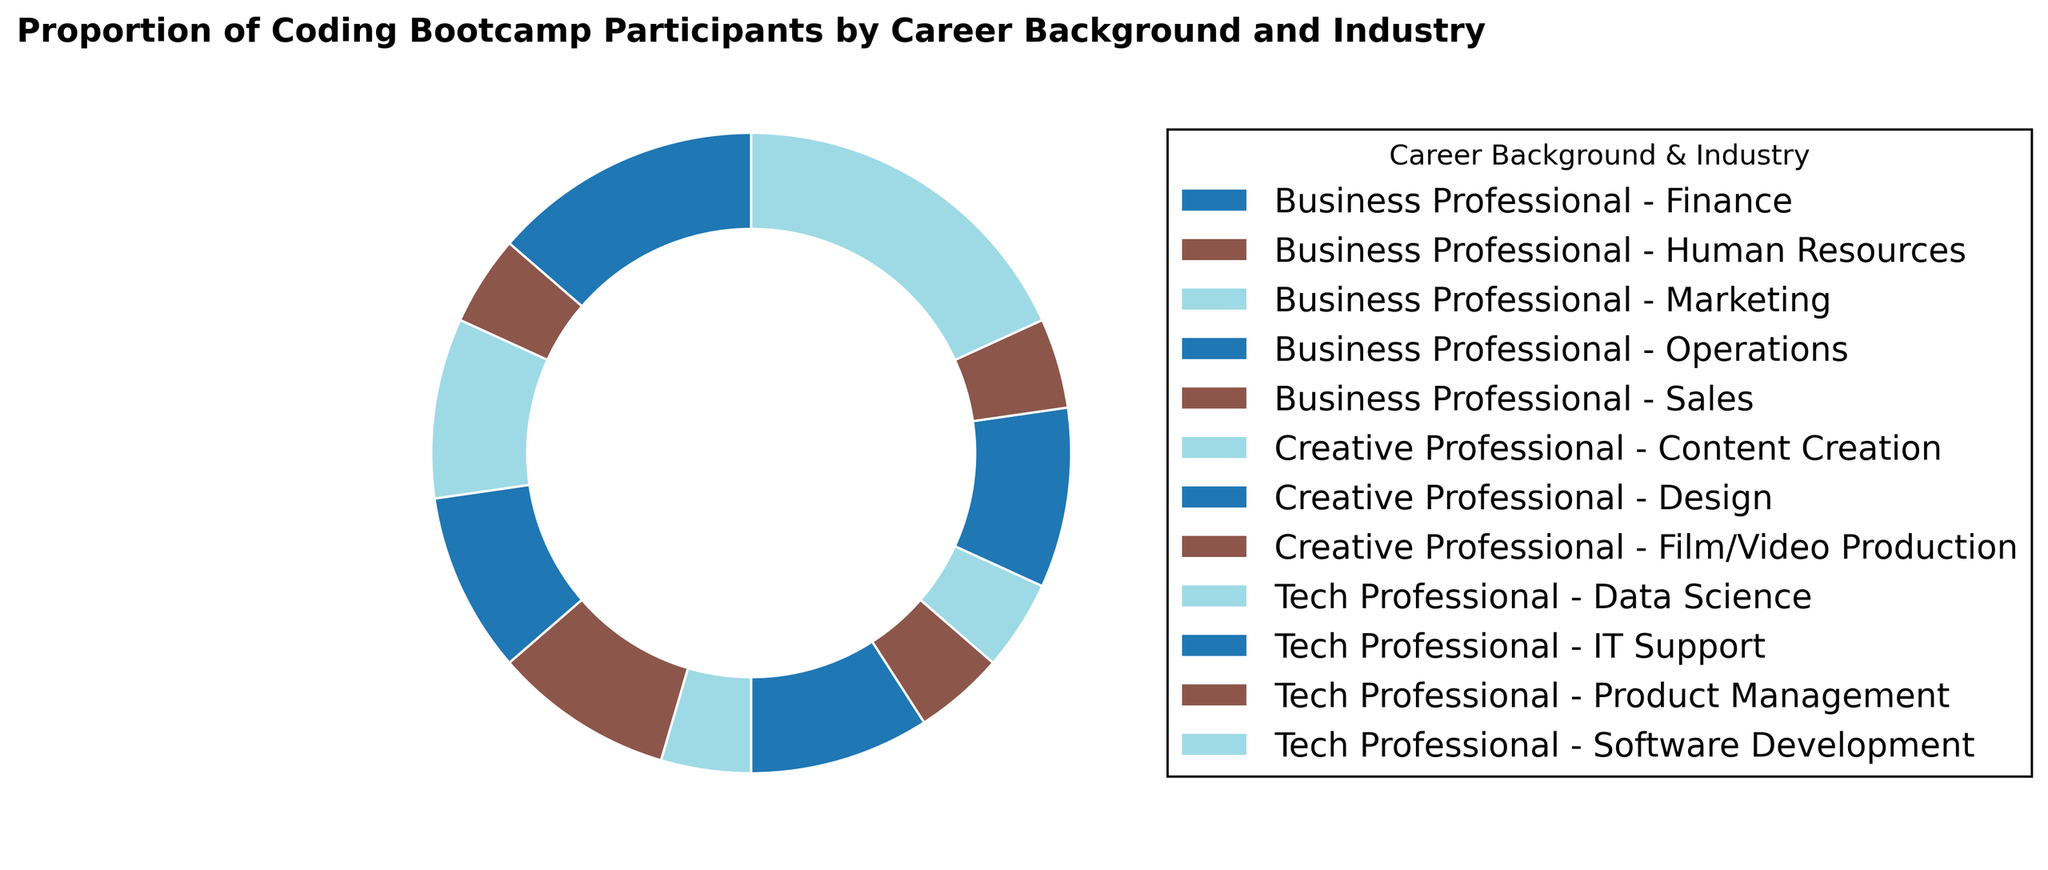What is the proportion of coding bootcamp participants from the Finance industry? To find the proportion, locate the wedge in the ring chart labeled "Business Professional - Finance". The proportion in this section is shown as a percentage.
Answer: 15% Which career background has the highest proportion of participants in the software development industry? The ring chart will show different career backgrounds by slices, and the slice labeled "Tech Professional - Software Development" has the highest percentage.
Answer: Tech Professional What is the total proportion of participants from the Business Professional background? Add up the proportions for all Business Professional industries: Finance (15%), Marketing (10%), Sales (10%), Human Resources (5%), Operations (10%). The sum is 15% + 10% + 10% + 5% + 10%.
Answer: 50% Which two industries have an equal proportion of participants? Compare the percentage slices in the ring chart. The two areas "Tech Professional - Data Science" and "Tech Professional - Product Management" both have 5% of participants.
Answer: Data Science and Product Management How does the proportion of participants from Marketing compare to those in Design? Compare the wedges labeled "Business Professional - Marketing" and "Creative Professional - Design". Both segments have the same size representing equal proportions.
Answer: They are equal Which career background has the smallest representation in the ring chart? Look for the career background that has the least combined proportion. "Creative Professional" makes up a small part with only three industries: Design (10%), Content Creation (5%), and Film/Video Production (5%).
Answer: Creative Professional Is the proportion of participants in IT Support greater than those in Sales? Compare the sizes of the "Tech Professional - IT Support" and "Business Professional - Sales" wedges. Both have a 10% proportion, so neither is greater.
Answer: No What is the combined proportion of participants from both the Creative and Tech Professional backgrounds? Add up the proportions for all Creative and Tech Professional industries: Design (10%), Content Creation (5%), Film/Video Production (5%), Software Development (20%), IT Support (10%), Product Management (5%), and Data Science (5%). The total is: 10% + 5% + 5% + 20% + 10% + 5% + 5%.
Answer: 60% Which industry within the Business Professional background has the smallest proportion of participants? Look at the wedges under the Business Professional category. The "Human Resources" industry has the smallest proportion at 5%.
Answer: Human Resources How does the proportion of participants in Operations compare to those in Product Management and Content Creation combined? Add the proportions for "Tech Professional - Product Management" and "Creative Professional - Content Creation". Both have 5%, so the combined is 5% + 5% = 10%. Compare this to "Business Professional - Operations" which is 10%. They are equal.
Answer: They are equal 